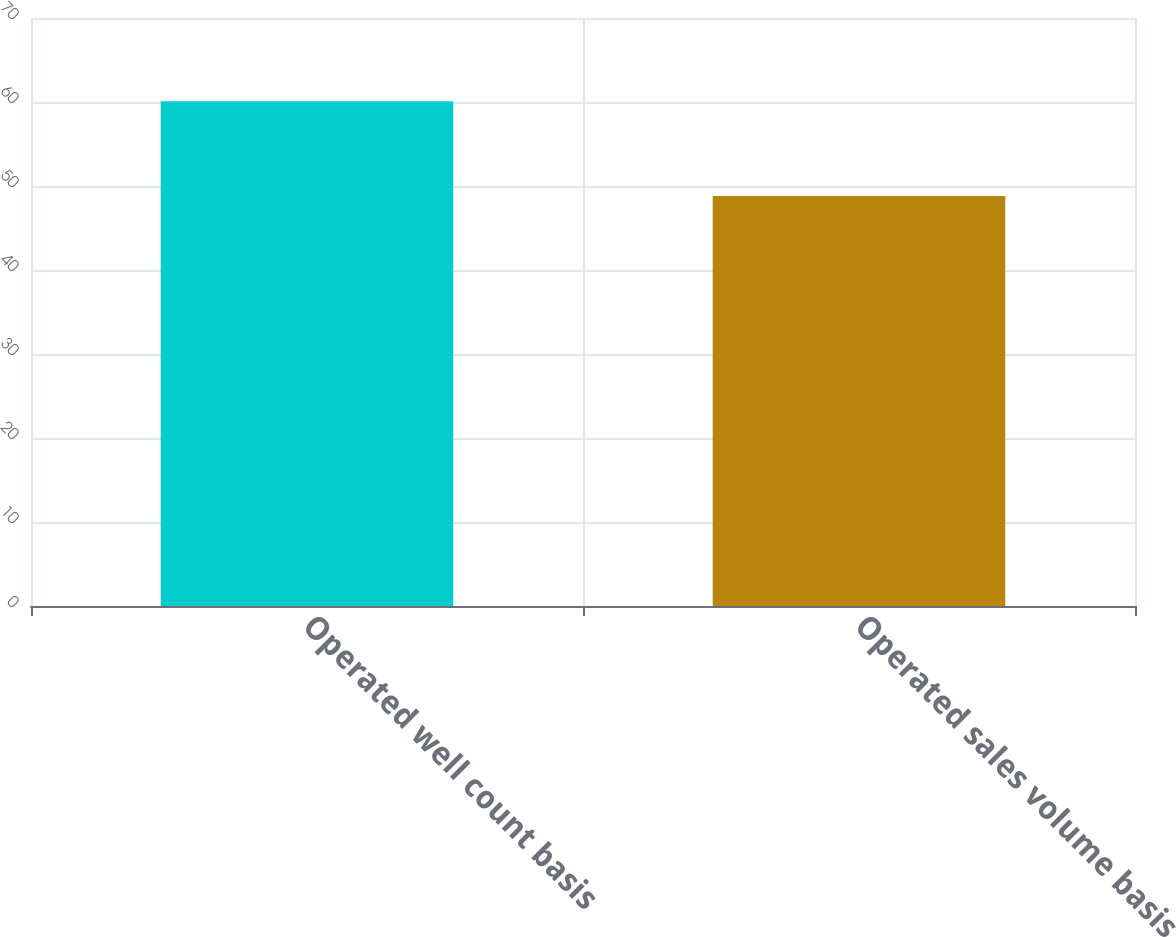<chart> <loc_0><loc_0><loc_500><loc_500><bar_chart><fcel>Operated well count basis<fcel>Operated sales volume basis<nl><fcel>60.1<fcel>48.8<nl></chart> 